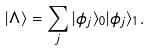Convert formula to latex. <formula><loc_0><loc_0><loc_500><loc_500>| \Lambda \rangle = \sum _ { j } | \phi _ { j } \rangle _ { 0 } | \phi _ { j } \rangle _ { 1 } .</formula> 